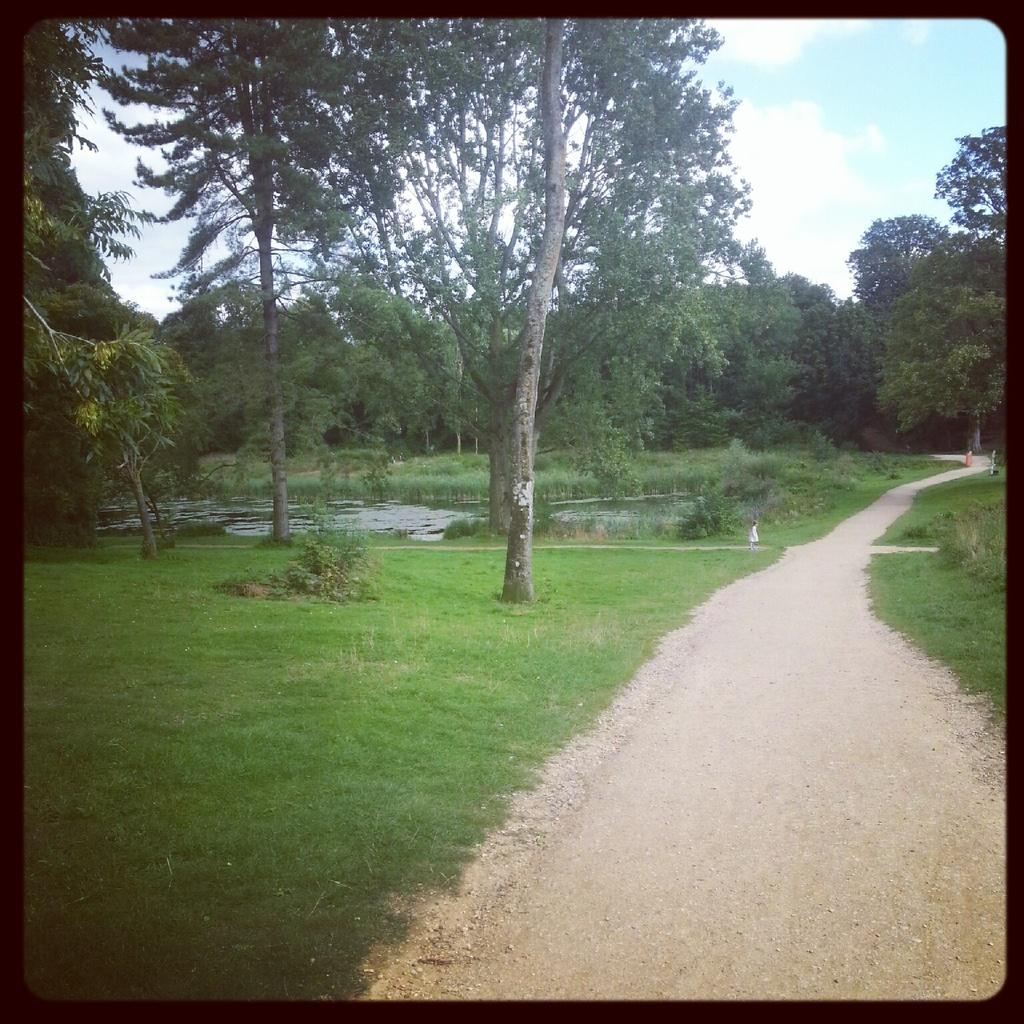What type of vegetation can be seen in the image? There are trees and plants visible in the image. What is the ground covered with in the image? Grass is present on the ground in the image. What can be seen in the water in the image? The facts do not specify what can be seen in the water. What is the condition of the sky in the image? The sky is blue and cloudy in the image. Is there a designated area for walking in the image? Yes, there is a path to walk in the image. What type of lace can be seen on the trees in the image? There is no lace present on the trees in the image. Who is the achiever in the image? The facts do not mention any specific individuals or achievements in the image. 